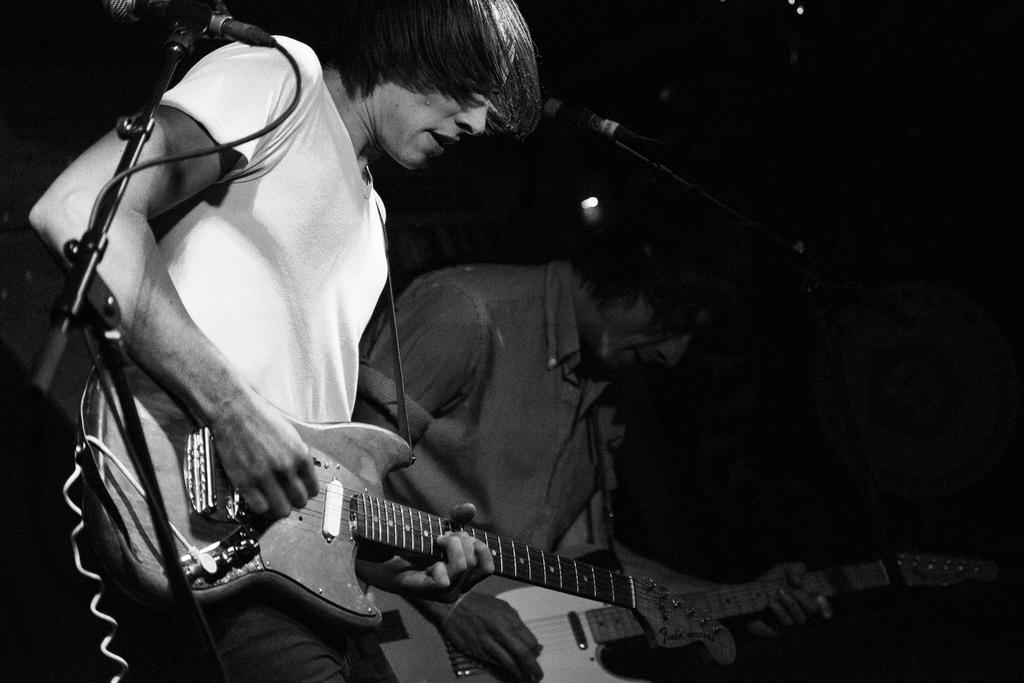How many people are in the image? There are two men in the image. What are the men doing in the image? The men are playing guitars. What object is in front of the men? There is a stand in front of the men. What can be seen behind the men? The background of the image is dark. Can you see a turkey flying in the background of the image? No, there is no turkey or any flying object visible in the image. How many times do the men turn around in the image? The men are not turning around in the image; they are playing guitars and facing the stand. 